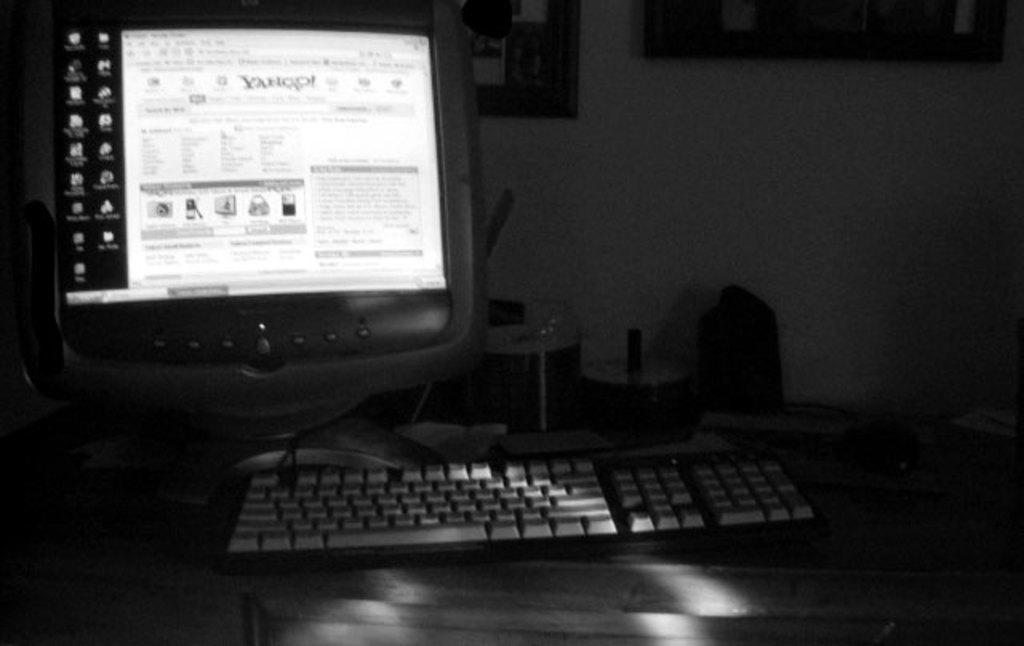<image>
Summarize the visual content of the image. A computer monitor with keyboard on a desk, screen is on Yahoo search webpage. 